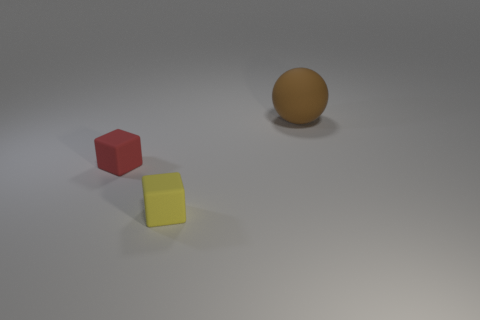There is a thing in front of the red block; is its size the same as the red rubber object?
Provide a short and direct response. Yes. Are there any other things that have the same size as the brown sphere?
Offer a terse response. No. Are there more cubes that are behind the yellow rubber cube than red rubber things to the right of the red block?
Provide a short and direct response. Yes. There is a rubber thing that is right of the tiny cube that is to the right of the tiny matte object behind the tiny yellow object; what is its color?
Make the answer very short. Brown. What number of other objects are there of the same color as the large rubber object?
Your response must be concise. 0. What number of things are either small green spheres or small objects?
Keep it short and to the point. 2. What number of things are matte things or tiny things on the left side of the yellow rubber object?
Provide a short and direct response. 3. Are the yellow cube and the brown object made of the same material?
Your answer should be compact. Yes. Are there more tiny purple rubber things than yellow blocks?
Provide a succinct answer. No. There is a matte thing to the right of the yellow rubber thing; is it the same shape as the small red thing?
Provide a succinct answer. No. 